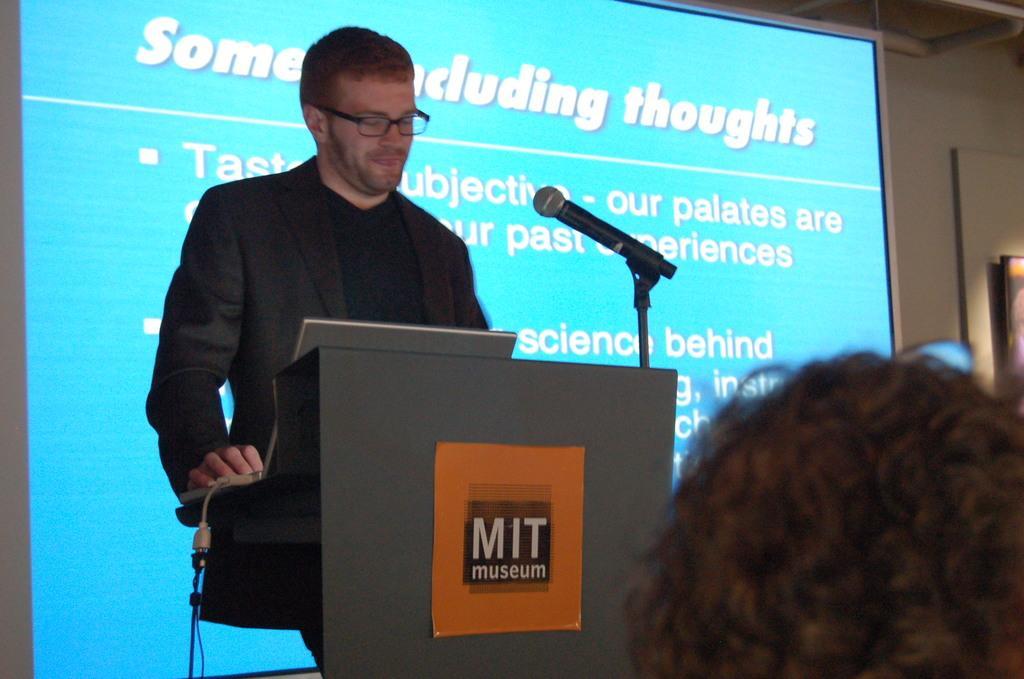In one or two sentences, can you explain what this image depicts? In this image I see a man who is standing in front of the podium and I see that the man is wearing a suit and I see a mic over here and I see a paper on which there are words written and in the background I see the screen on which there are words written and I see the white wall and I see the human hair over here. 